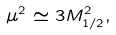<formula> <loc_0><loc_0><loc_500><loc_500>\mu ^ { 2 } \simeq 3 M _ { 1 / 2 } ^ { 2 } ,</formula> 